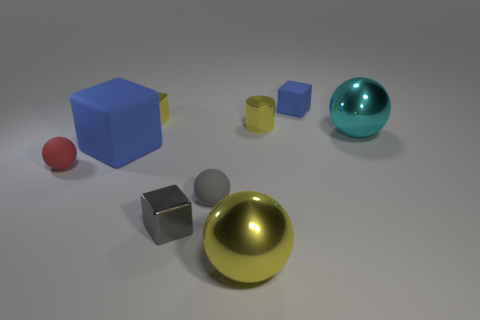Subtract 1 blocks. How many blocks are left? 3 Add 1 large yellow objects. How many objects exist? 10 Subtract all spheres. How many objects are left? 5 Subtract 1 red spheres. How many objects are left? 8 Subtract all large cyan objects. Subtract all yellow shiny spheres. How many objects are left? 7 Add 2 large cyan shiny balls. How many large cyan shiny balls are left? 3 Add 1 large blue matte things. How many large blue matte things exist? 2 